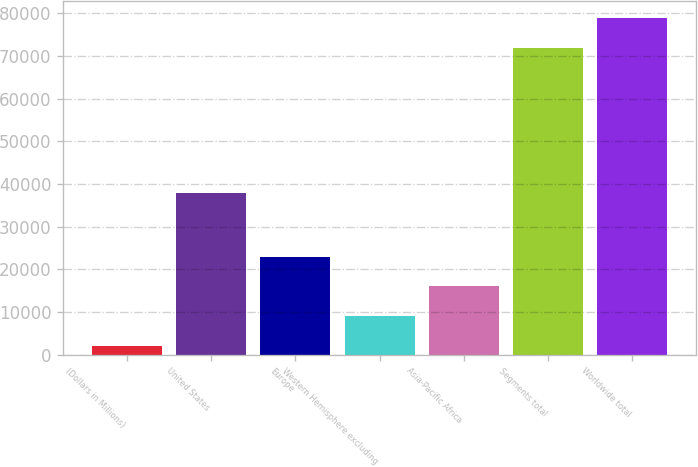Convert chart. <chart><loc_0><loc_0><loc_500><loc_500><bar_chart><fcel>(Dollars in Millions)<fcel>United States<fcel>Europe<fcel>Western Hemisphere excluding<fcel>Asia-Pacific Africa<fcel>Segments total<fcel>Worldwide total<nl><fcel>2016<fcel>37811<fcel>22978.2<fcel>9003.4<fcel>15990.8<fcel>71890<fcel>78877.4<nl></chart> 